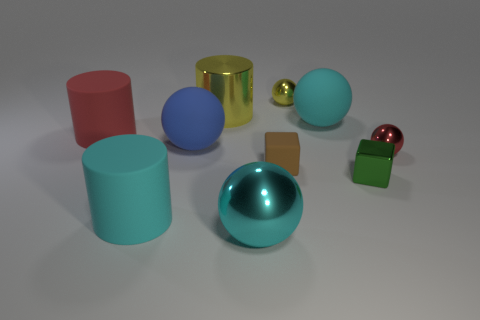What number of other things are the same shape as the small rubber object?
Offer a terse response. 1. There is a large cylinder in front of the brown thing; is it the same color as the large rubber ball that is behind the big red thing?
Make the answer very short. Yes. What color is the other matte sphere that is the same size as the cyan rubber ball?
Provide a short and direct response. Blue. Is there a ball that has the same color as the big shiny cylinder?
Your answer should be compact. Yes. Do the yellow thing on the right side of the cyan shiny sphere and the large cyan matte sphere have the same size?
Provide a short and direct response. No. Are there an equal number of large matte spheres that are right of the yellow ball and tiny shiny blocks?
Give a very brief answer. Yes. What number of objects are either big objects behind the large red matte cylinder or big cyan things?
Your response must be concise. 4. What is the shape of the object that is both left of the tiny brown rubber cube and behind the cyan matte ball?
Offer a very short reply. Cylinder. How many objects are cylinders to the left of the brown rubber cube or red things that are in front of the large red object?
Offer a terse response. 4. How many other objects are the same size as the cyan metal object?
Ensure brevity in your answer.  5. 